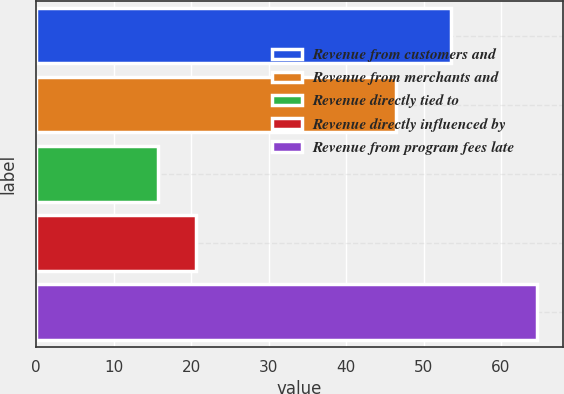Convert chart to OTSL. <chart><loc_0><loc_0><loc_500><loc_500><bar_chart><fcel>Revenue from customers and<fcel>Revenue from merchants and<fcel>Revenue directly tied to<fcel>Revenue directly influenced by<fcel>Revenue from program fees late<nl><fcel>53.6<fcel>46.4<fcel>15.7<fcel>20.6<fcel>64.7<nl></chart> 